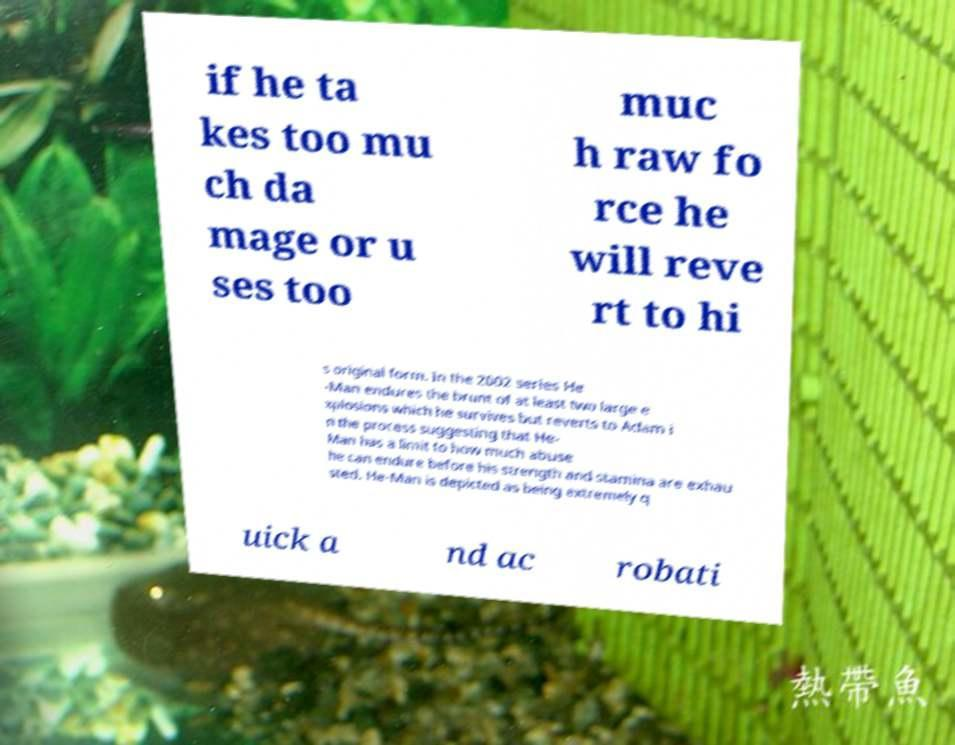Please identify and transcribe the text found in this image. if he ta kes too mu ch da mage or u ses too muc h raw fo rce he will reve rt to hi s original form. In the 2002 series He -Man endures the brunt of at least two large e xplosions which he survives but reverts to Adam i n the process suggesting that He- Man has a limit to how much abuse he can endure before his strength and stamina are exhau sted. He-Man is depicted as being extremely q uick a nd ac robati 